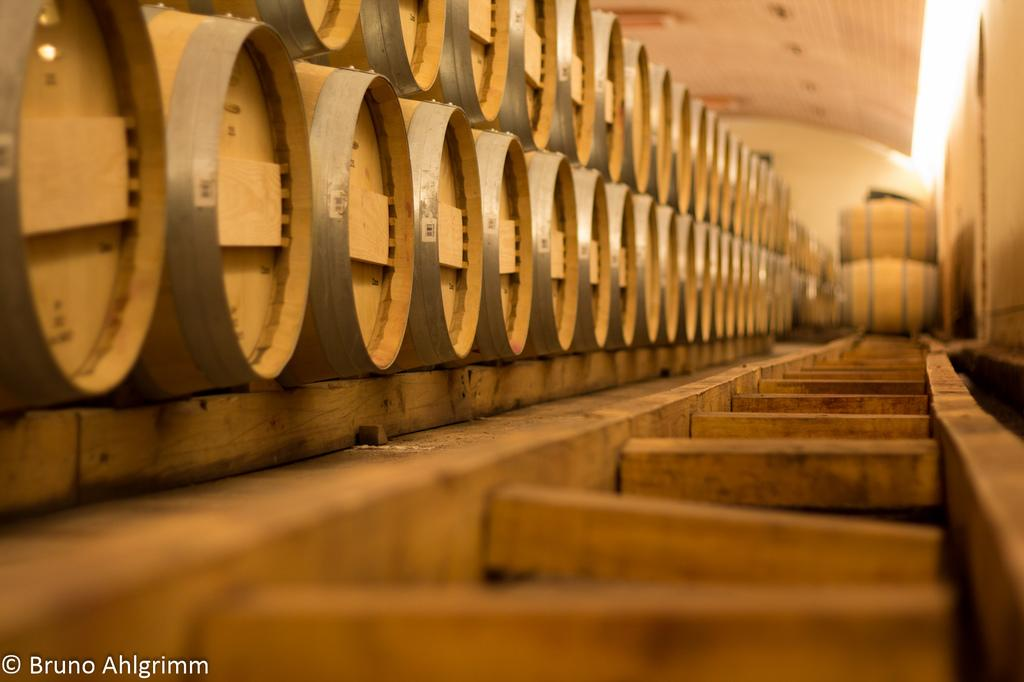What type of musical instruments are present in the image? There are many drums in the image. What material is at the bottom of the image? There is wood at the bottom of the image. What can be seen written or printed in the image? There is some text visible in the image. What structure is visible at the top of the image? There is a roof at the top of the image. What type of paper is being used by the flock of birds in the image? There are no birds or paper present in the image. How many songs can be heard being played on the drums in the image? The image does not provide any information about the songs being played on the drums. 